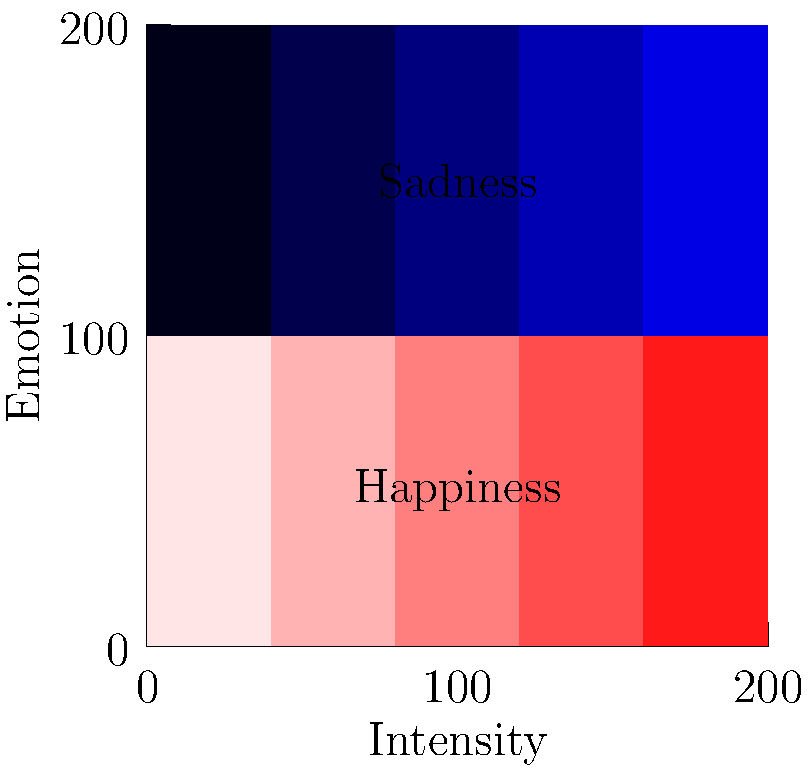As a K-drama director, you're working on a scene where the main character transitions from extreme happiness to deep sadness. Based on the color palette shown in the diagram, which combination of colors would best represent this emotional journey in your production design? To answer this question, let's analyze the color palette provided in the diagram:

1. The diagram shows two rows of colors, representing happiness (top row) and sadness (bottom row).
2. Each row has 5 shades, transitioning from left to right.
3. For happiness:
   - It starts with a bright red (RGB: 1,0.9,0.9) on the left
   - It gradually fades to a pale pink (RGB: 1,0.1,0.1) on the right
4. For sadness:
   - It begins with a very light blue (RGB: 0,0,0.1) on the left
   - It intensifies to a deep blue (RGB: 0,0,0.9) on the right
5. To represent the transition from extreme happiness to deep sadness:
   - We should start with the leftmost color in the happiness row (bright red)
   - We should end with the rightmost color in the sadness row (deep blue)
6. This combination would visually represent the character's emotional journey from the highest point of happiness to the lowest point of sadness.

Therefore, the best color combination to represent this emotional transition would be from bright red (RGB: 1,0.9,0.9) to deep blue (RGB: 0,0,0.9).
Answer: Bright red (RGB: 1,0.9,0.9) to deep blue (RGB: 0,0,0.9) 